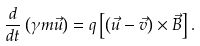<formula> <loc_0><loc_0><loc_500><loc_500>\frac { d } { d t } \left ( \gamma m \vec { u } \right ) = q \left [ \left ( \vec { u } - \vec { v } \right ) \times \vec { B } \right ] .</formula> 